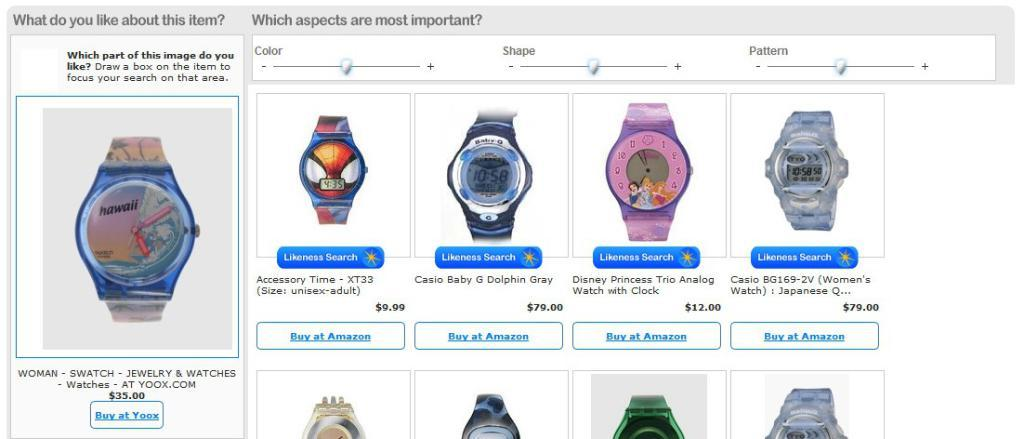<image>
Create a compact narrative representing the image presented. screen showing watches and words "What do you like about this item" 